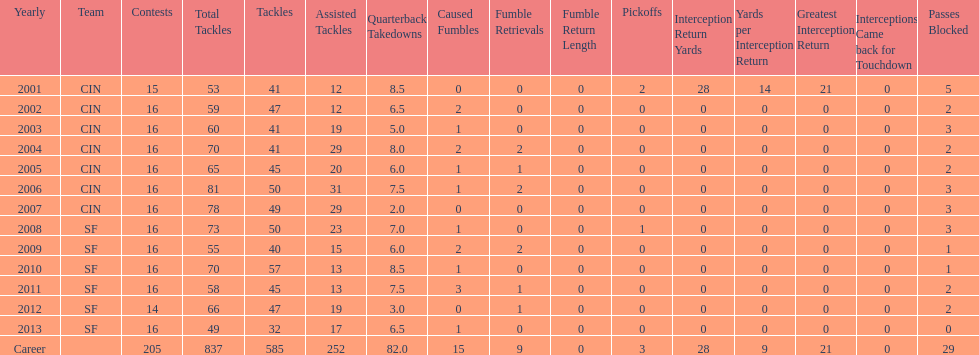How many fumble recoveries did this player have in 2004? 2. Parse the full table. {'header': ['Yearly', 'Team', 'Contests', 'Total Tackles', 'Tackles', 'Assisted Tackles', 'Quarterback Takedowns', 'Caused Fumbles', 'Fumble Retrievals', 'Fumble Return Length', 'Pickoffs', 'Interception Return Yards', 'Yards per Interception Return', 'Greatest Interception Return', 'Interceptions Came back for Touchdown', 'Passes Blocked'], 'rows': [['2001', 'CIN', '15', '53', '41', '12', '8.5', '0', '0', '0', '2', '28', '14', '21', '0', '5'], ['2002', 'CIN', '16', '59', '47', '12', '6.5', '2', '0', '0', '0', '0', '0', '0', '0', '2'], ['2003', 'CIN', '16', '60', '41', '19', '5.0', '1', '0', '0', '0', '0', '0', '0', '0', '3'], ['2004', 'CIN', '16', '70', '41', '29', '8.0', '2', '2', '0', '0', '0', '0', '0', '0', '2'], ['2005', 'CIN', '16', '65', '45', '20', '6.0', '1', '1', '0', '0', '0', '0', '0', '0', '2'], ['2006', 'CIN', '16', '81', '50', '31', '7.5', '1', '2', '0', '0', '0', '0', '0', '0', '3'], ['2007', 'CIN', '16', '78', '49', '29', '2.0', '0', '0', '0', '0', '0', '0', '0', '0', '3'], ['2008', 'SF', '16', '73', '50', '23', '7.0', '1', '0', '0', '1', '0', '0', '0', '0', '3'], ['2009', 'SF', '16', '55', '40', '15', '6.0', '2', '2', '0', '0', '0', '0', '0', '0', '1'], ['2010', 'SF', '16', '70', '57', '13', '8.5', '1', '0', '0', '0', '0', '0', '0', '0', '1'], ['2011', 'SF', '16', '58', '45', '13', '7.5', '3', '1', '0', '0', '0', '0', '0', '0', '2'], ['2012', 'SF', '14', '66', '47', '19', '3.0', '0', '1', '0', '0', '0', '0', '0', '0', '2'], ['2013', 'SF', '16', '49', '32', '17', '6.5', '1', '0', '0', '0', '0', '0', '0', '0', '0'], ['Career', '', '205', '837', '585', '252', '82.0', '15', '9', '0', '3', '28', '9', '21', '0', '29']]} 